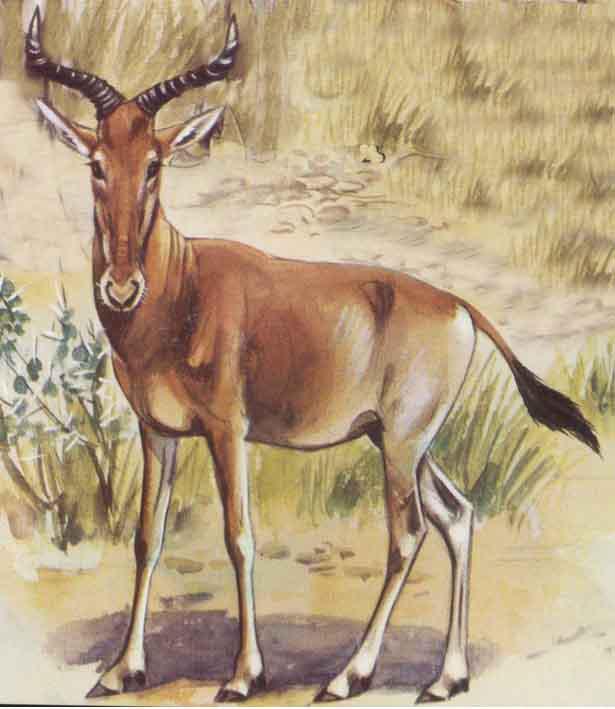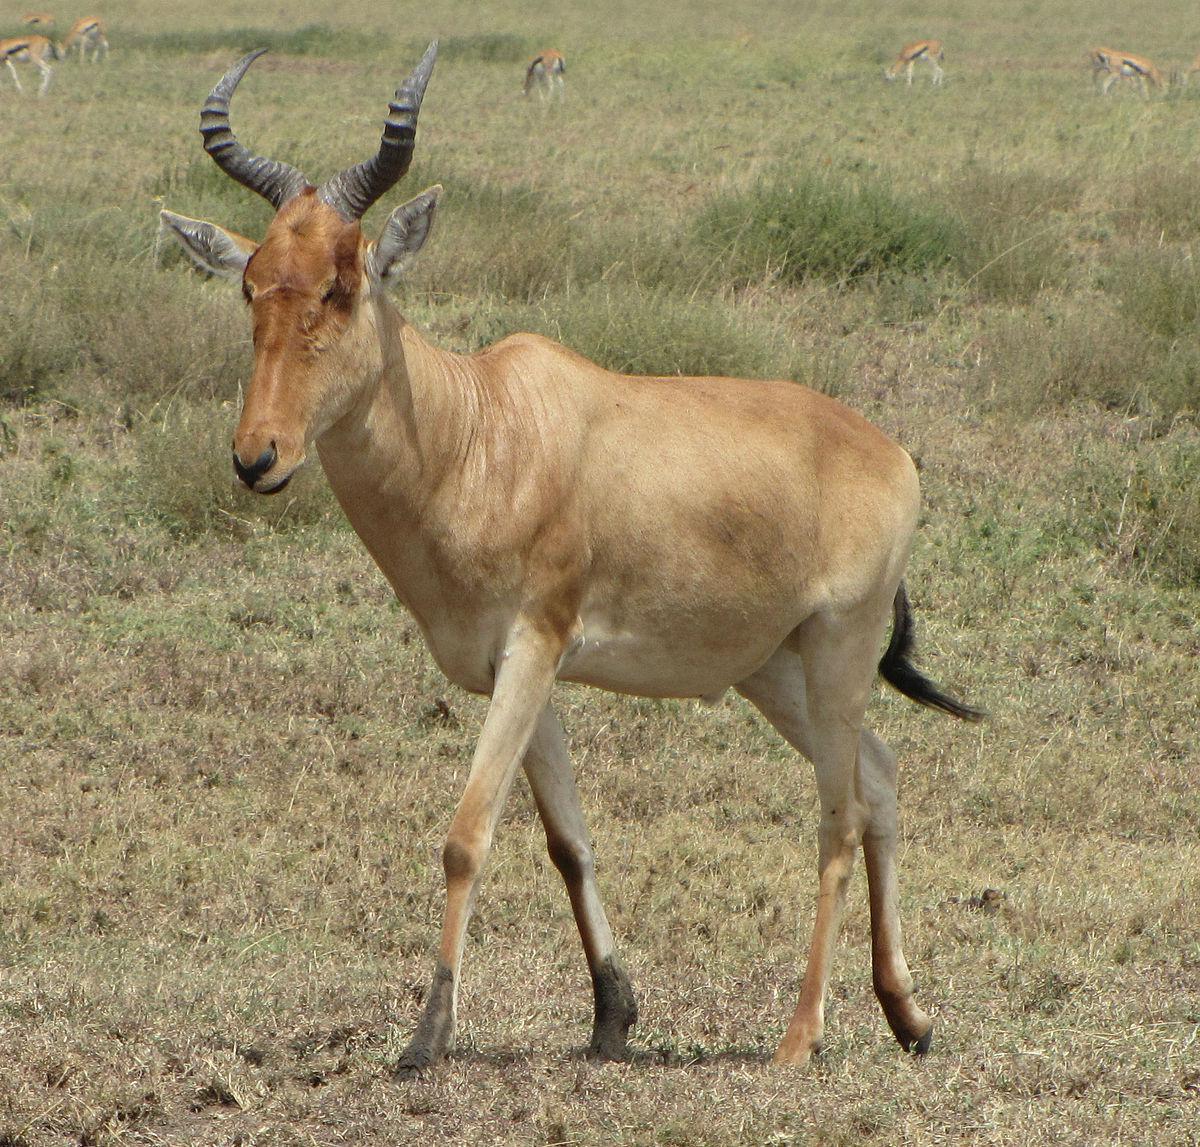The first image is the image on the left, the second image is the image on the right. Given the left and right images, does the statement "There are two different types of animals in one of the pictures." hold true? Answer yes or no. No. 